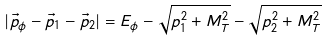<formula> <loc_0><loc_0><loc_500><loc_500>| \vec { p } _ { \phi } - \vec { p } _ { 1 } - \vec { p } _ { 2 } | = E _ { \phi } - \sqrt { p _ { 1 } ^ { 2 } + M _ { T } ^ { 2 } } - \sqrt { p _ { 2 } ^ { 2 } + M _ { T } ^ { 2 } }</formula> 